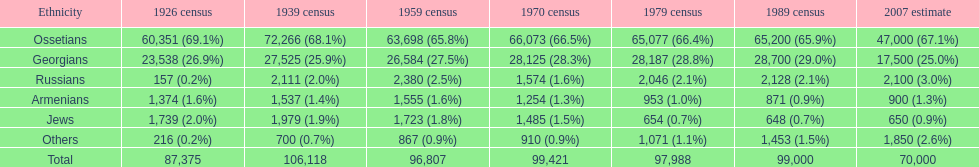Which racial group is at the peak? Ossetians. 